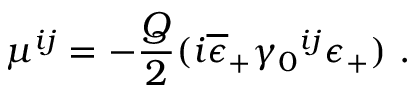Convert formula to latex. <formula><loc_0><loc_0><loc_500><loc_500>\mu ^ { i j } = - { \frac { Q } { 2 } } ( i \overline { \epsilon } _ { + } \gamma _ { 0 ^ { i j } \epsilon _ { + } ) \ .</formula> 